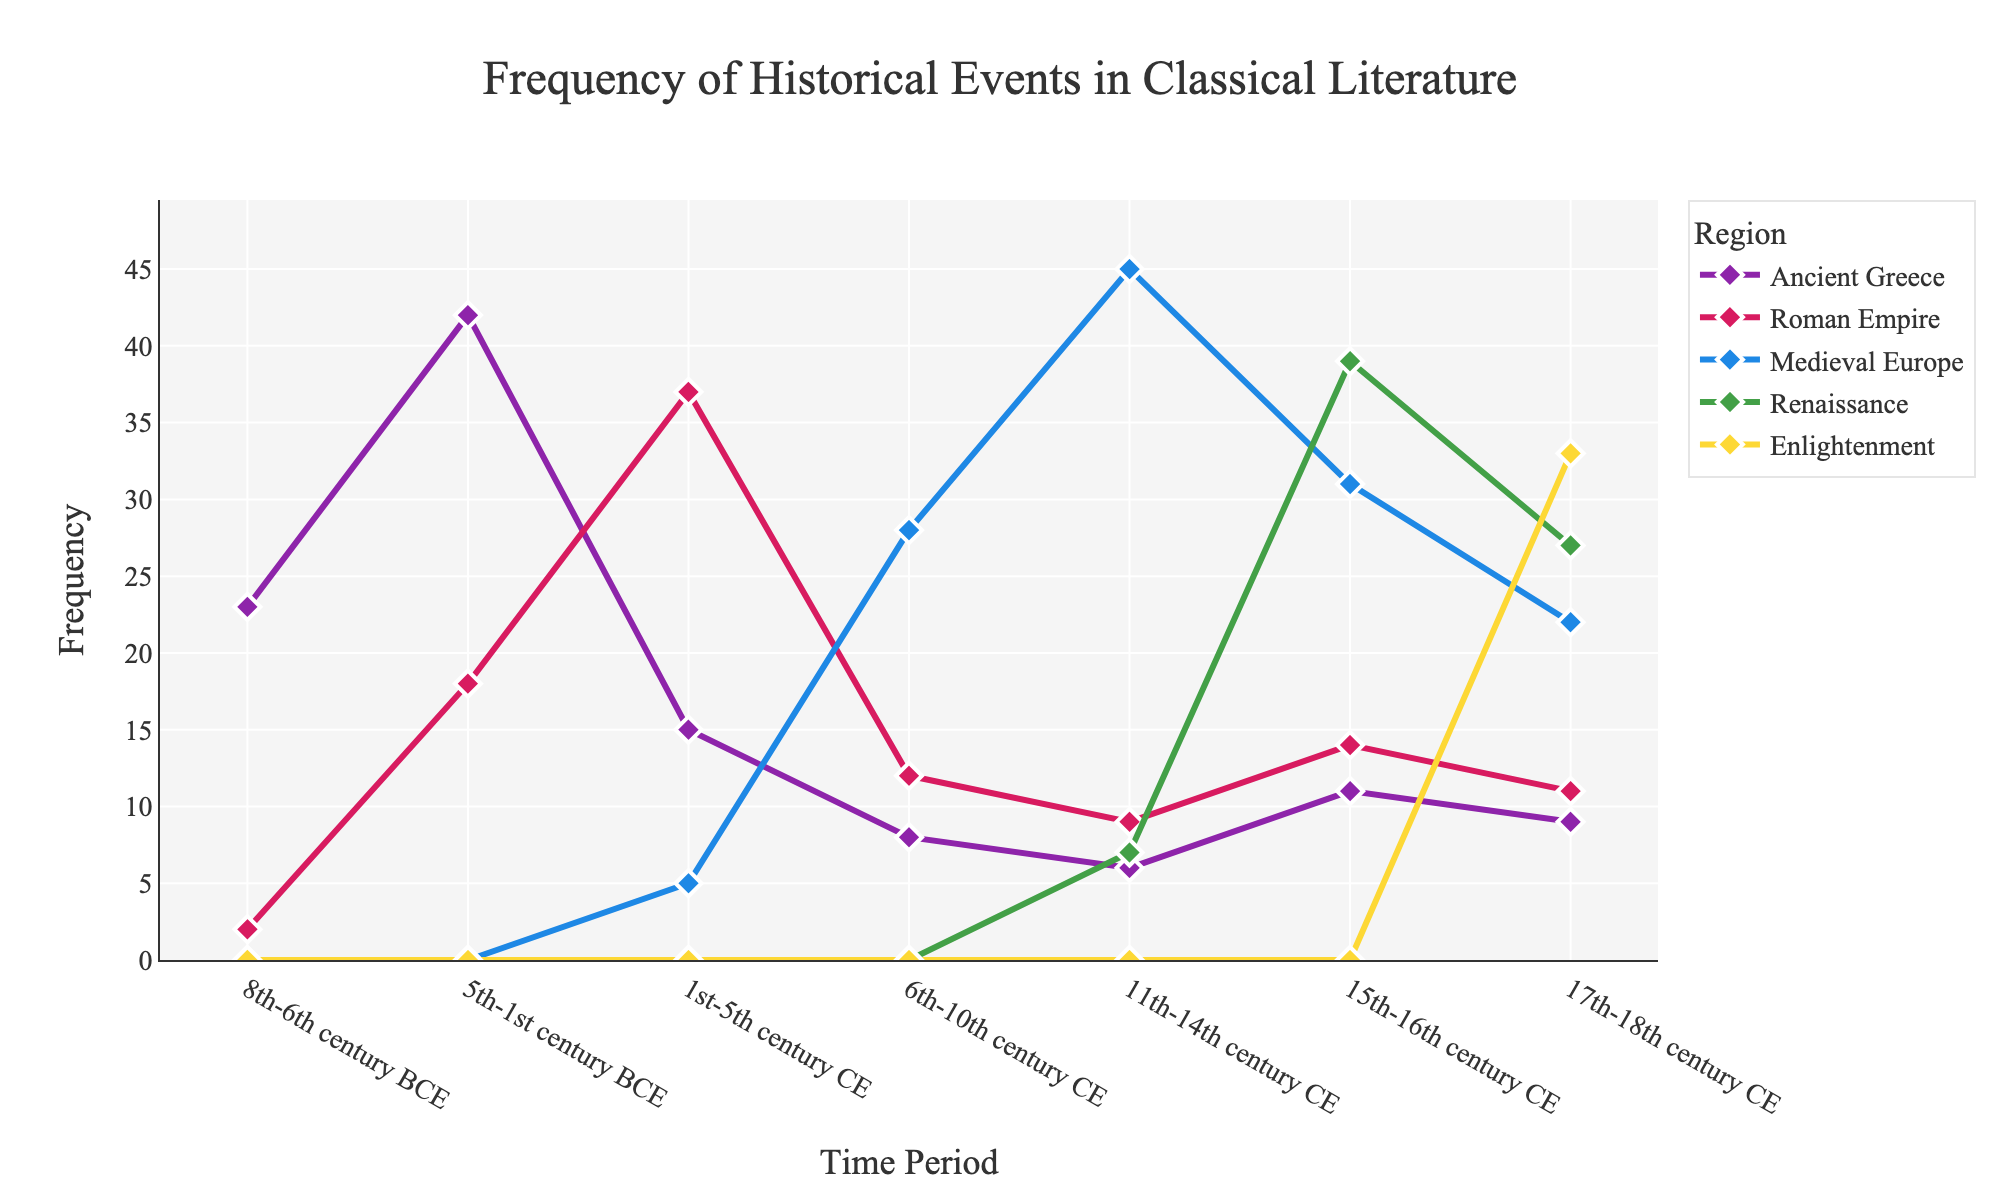Which time period mentions Ancient Greece most frequently? Observe the frequency line for Ancient Greece across all time periods and identify the highest point. The highest frequency for Ancient Greece occurs in the 5th-1st century BCE.
Answer: 5th-1st century BCE During which centuries does the frequency of Medieval Europe events exceed the frequency of Roman Empire events? Compare the lines for Medieval Europe and Roman Empire across different time periods. Medieval Europe has higher frequencies in the 6th-10th and 11th-14th centuries CE.
Answer: 6th-10th century CE, 11th-14th century CE What is the sum of frequencies for the Enlightenment period across all regions? Sum the frequencies for the Enlightenment across all regions in the 17th-18th century CE: 9 + 11 + 22 + 27 + 33.
Answer: 102 How does the frequency of Renaissance events in the 15th-16th century CE compare to the same period in the Roman Empire? Compare the height of the line representing Renaissance with that of the Roman Empire for the 15th-16th century CE. Renaissance has a frequency of 39, while Roman Empire has a frequency of 14.
Answer: Renaissance is higher In which colors are the periods of Enlightenment represented, and which region has the highest frequency? Observe the line colors associated with each region for the Enlightenment period. The Enlightenment line is golden yellow, and Ancient Greece (represented by purple) has the highest frequency.
Answer: Golden yellow, Ancient Greece Which region shows a gradual increase in frequency from the 6th-10th century to the 15th-16th century CE? Look for a line that steadily increases between these time periods. The frequency of Medieval Europe shows an increasing trend from 6th-10th to 15th-16th century CE.
Answer: Medieval Europe Which region dips in frequency after the Renaissance period until the Enlightenment? Identify which line decreases in frequency from the Renaissance (15th-16th century CE) to the Enlightenment (17th-18th century CE). The Renaissance region itself shows this decline.
Answer: Renaissance During the 11th-14th centuries CE, which two regions have the closest frequencies, and what are they? Compare the frequencies of different regions in this period and find the closest values. Roman Empire (9) and Ancient Greece (6) have the closest frequencies.
Answer: Roman Empire and Ancient Greece, 9 and 6 